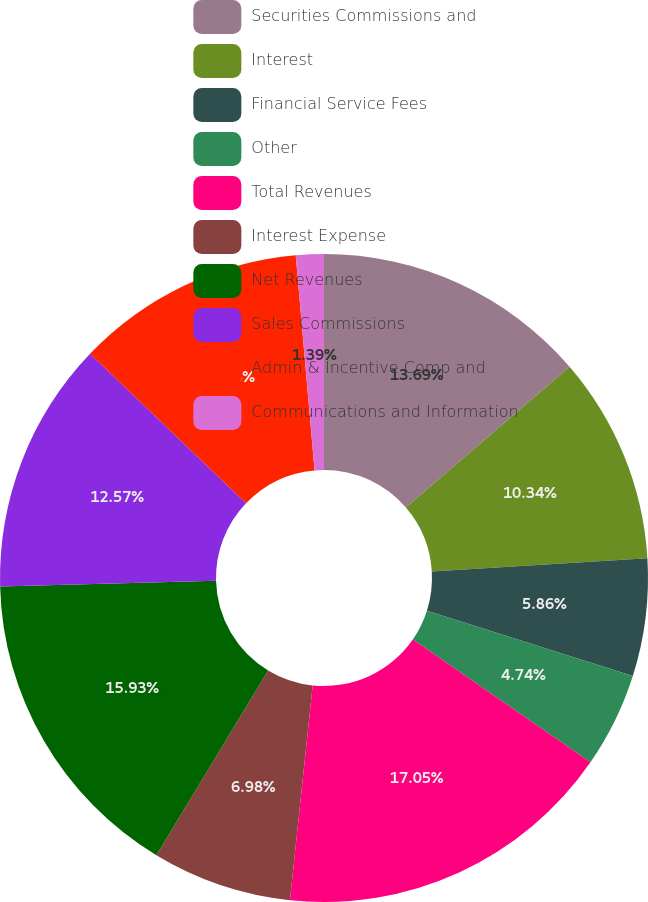Convert chart. <chart><loc_0><loc_0><loc_500><loc_500><pie_chart><fcel>Securities Commissions and<fcel>Interest<fcel>Financial Service Fees<fcel>Other<fcel>Total Revenues<fcel>Interest Expense<fcel>Net Revenues<fcel>Sales Commissions<fcel>Admin & Incentive Comp and<fcel>Communications and Information<nl><fcel>13.69%<fcel>10.34%<fcel>5.86%<fcel>4.74%<fcel>17.04%<fcel>6.98%<fcel>15.93%<fcel>12.57%<fcel>11.45%<fcel>1.39%<nl></chart> 